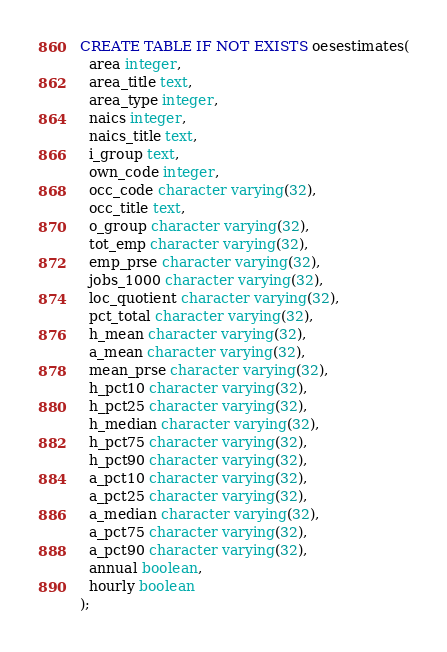Convert code to text. <code><loc_0><loc_0><loc_500><loc_500><_SQL_>CREATE TABLE IF NOT EXISTS oesestimates(
  area integer,
  area_title text,
  area_type integer,
  naics integer,
  naics_title text,
  i_group text,
  own_code integer,
  occ_code character varying(32),
  occ_title text,
  o_group character varying(32),
  tot_emp character varying(32),
  emp_prse character varying(32),
  jobs_1000 character varying(32),
  loc_quotient character varying(32),
  pct_total character varying(32),
  h_mean character varying(32),
  a_mean character varying(32),
  mean_prse character varying(32),
  h_pct10 character varying(32),
  h_pct25 character varying(32),
  h_median character varying(32),
  h_pct75 character varying(32),
  h_pct90 character varying(32),
  a_pct10 character varying(32),
  a_pct25 character varying(32),
  a_median character varying(32),
  a_pct75 character varying(32),
  a_pct90 character varying(32),
  annual boolean,
  hourly boolean
);

</code> 